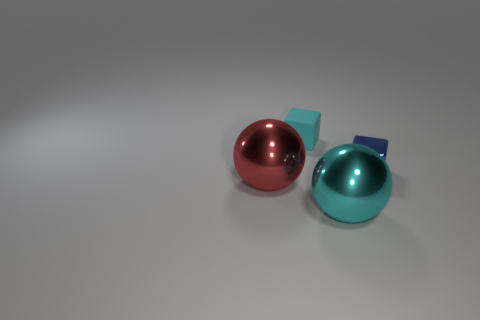Add 1 green spheres. How many objects exist? 5 Add 4 cubes. How many cubes are left? 6 Add 3 blue cubes. How many blue cubes exist? 4 Subtract 0 gray spheres. How many objects are left? 4 Subtract all metal cubes. Subtract all big metallic objects. How many objects are left? 1 